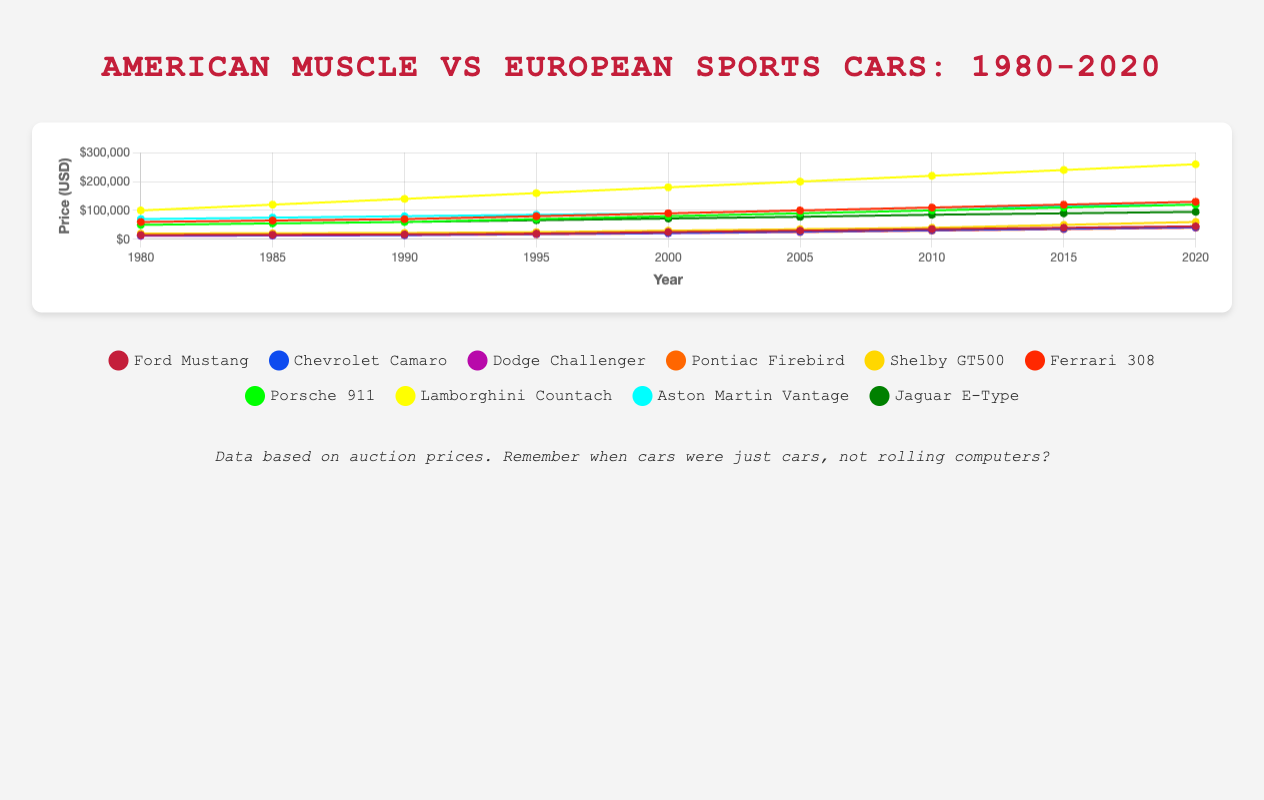Which American muscle car had the highest auction price in 2020? To determine the highest auction price for American muscle cars in 2020, look at the final data points for each listed American muscle car in the chart. The Shelby GT500 has the highest price at $60,000
Answer: Shelby GT500 Between the Ford Mustang and the Porsche 911, which had a higher price in 1995 and by how much? In 1995, the Ford Mustang was priced at $20,000, and the Porsche 911 was priced at $70,000. The difference in price is $70,000 - $20,000 = $50,000
Answer: $50,000 On average, how much did the auction price of the Dodge Challenger increase between 1980 and 2020? The price of the Dodge Challenger increased from $12,000 in 1980 to $41,000 in 2020. The increase is $41,000 - $12,000 = $29,000. To find the average annual increase over 40 years, we divide $29,000 by 40 years, which results in an average increase of $725 per year
Answer: $725 per year Which car had the steepest increase in price from 2010 to 2020, the Ford Mustang or the Ferrari 308? For the Ford Mustang, the price in 2010 was $35,000 and in 2020 was $45,000, making the increase $45,000 - $35,000 = $10,000. For the Ferrari 308, the price in 2010 was $110,000, and in 2020 was $130,000, making the increase $130,000 - $110,000 = $20,000. The Ferrari 308 had the steeper increase
Answer: Ferrari 308 What is the overall trend for auction prices of American muscle cars from 1980 to 2020? Observing the chart, all American muscle cars have steadily increased in auction price over the period from 1980 to 2020
Answer: Steady increase Which European sports car had the lowest auction price in 2000? In 2000, the Jaguar E-Type had the lowest price among European sports cars at $72,000
Answer: Jaguar E-Type Did any car's auction price decrease in any year between 1980 and 2020? By examining the chart, all cars show a trend of increasing prices over time, without any evident decreases in any year
Answer: No Compare the price trends of the Chevrolet Camaro and the Pontiac Firebird between 2005 and 2015 The chart shows that from 2005 to 2015, both the Chevrolet Camaro and the Pontiac Firebird increased in auction price. The Camaro went from $27,000 to $37,000, and the Firebird went from $25,000 to $35,000. Both show similar increasing trends
Answer: Similar increasing trends What's the average auction price for the Aston Martin Vantage over the entire period? The prices of Aston Martin Vantage from 1980 to 2020 are $70,000, $75,000, $80,000, $85,000, $90,000, $100,000, $110,000, $115,000, and $120,000. Summing these values gives $845,000. The average is $845,000 / 9 = $93,889
Answer: $93,889 